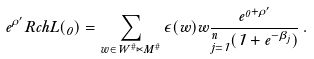<formula> <loc_0><loc_0><loc_500><loc_500>e ^ { \rho ^ { \prime } } R c h L ( \Lambda _ { 0 } ) = \sum _ { w \in W ^ { \# } \ltimes M ^ { \# } } \epsilon ( w ) w \frac { e ^ { \Lambda _ { 0 } + \rho ^ { \prime } } } { \Pi ^ { n } _ { j = 1 } ( 1 + e ^ { - \beta _ { j } } ) } \, .</formula> 